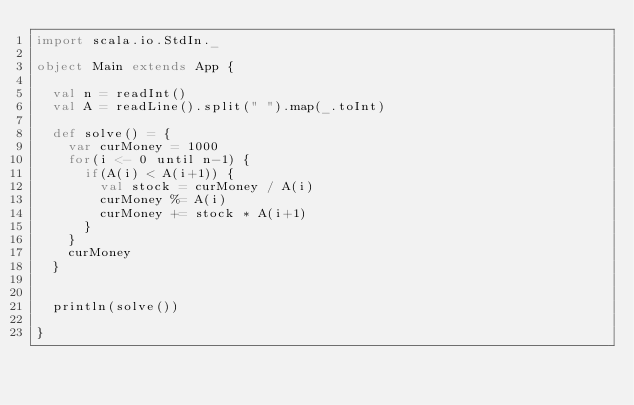<code> <loc_0><loc_0><loc_500><loc_500><_Scala_>import scala.io.StdIn._

object Main extends App {

  val n = readInt()
  val A = readLine().split(" ").map(_.toInt)

  def solve() = {
    var curMoney = 1000
    for(i <- 0 until n-1) {
      if(A(i) < A(i+1)) {
        val stock = curMoney / A(i)
        curMoney %= A(i)
        curMoney += stock * A(i+1)
      }
    }
    curMoney
  }


  println(solve())

}

</code> 